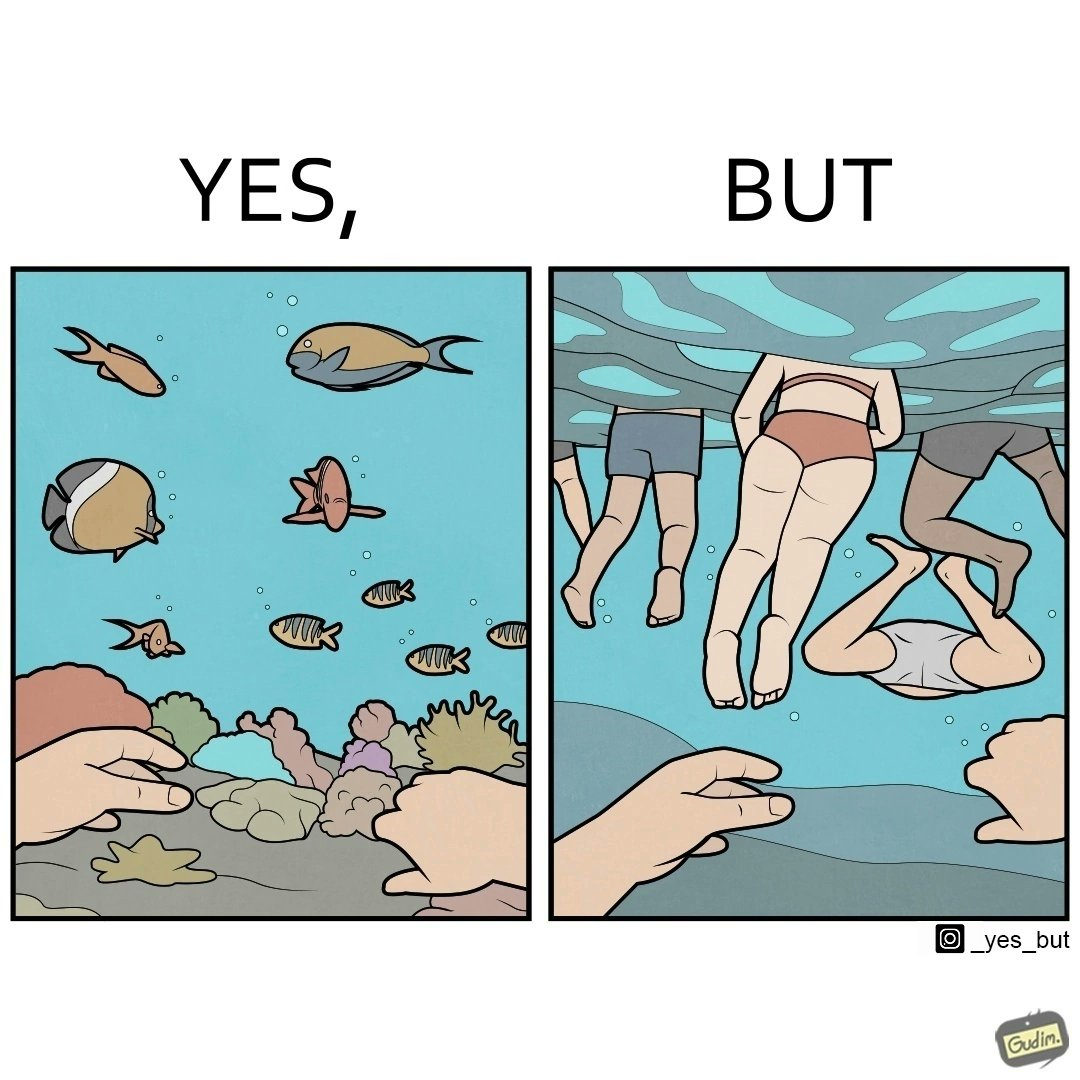Would you classify this image as satirical? Yes, this image is satirical. 